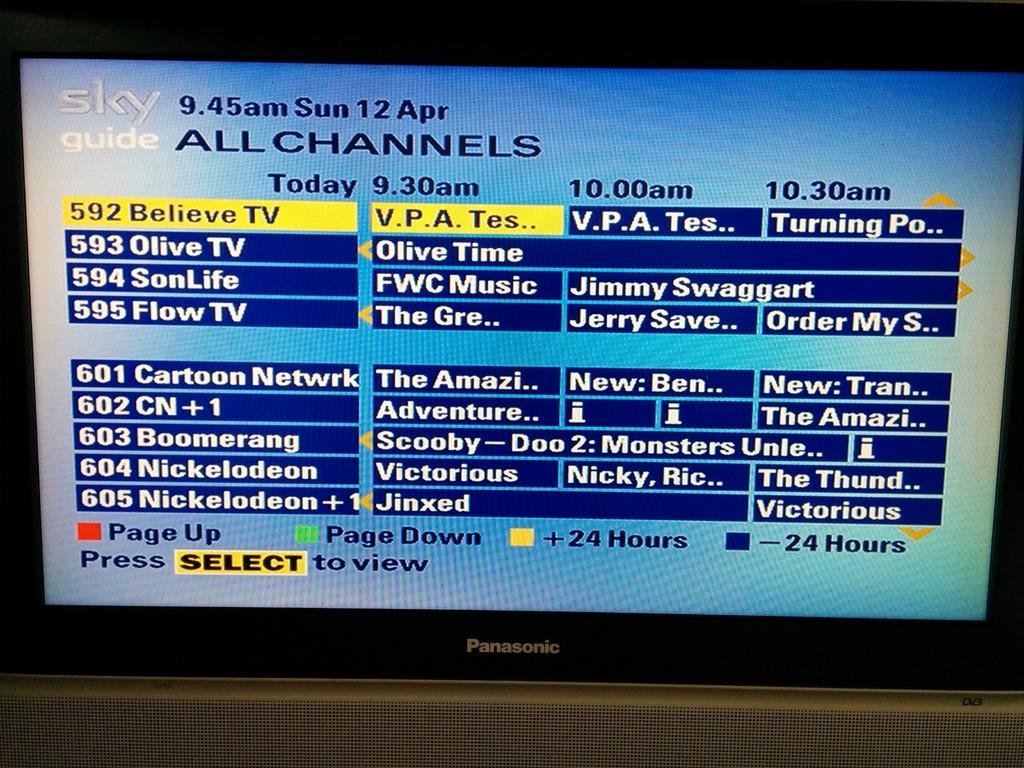What is the name of this guide?
Offer a very short reply. Sky guide. What time does scooby doo start?
Provide a short and direct response. 9:30am. 